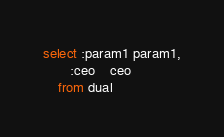Convert code to text. <code><loc_0><loc_0><loc_500><loc_500><_SQL_>select :param1 param1,
       :ceo    ceo
    from dual
</code> 